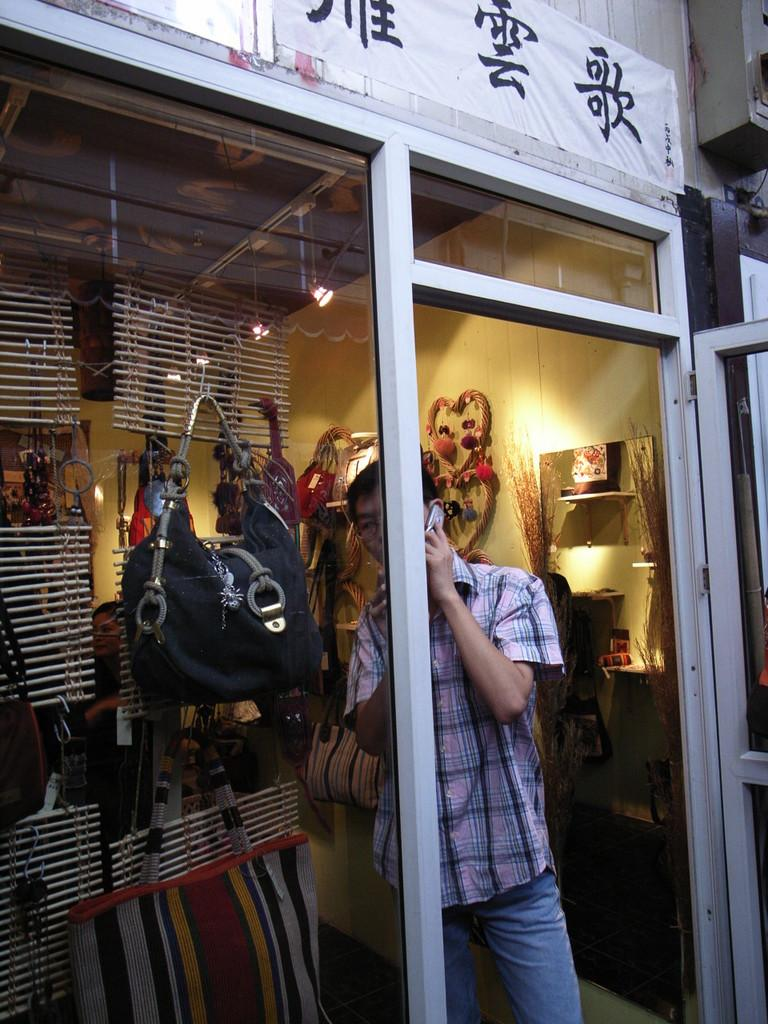Who is present in the image? There is a person in the image. What is the person holding in the image? The person is holding a mobile phone. Where is the person located in the image? The person is standing inside a store. What can be observed about the store's interior? There are many things hanging in the store. What type of wall can be seen in the store? The store has a glass wall. What type of dinner is being served in the image? There is no dinner present in the image; it features a person holding a mobile phone inside a store. How does the person's knowledge of the store's inventory affect the image? The image does not provide any information about the person's knowledge of the store's inventory. 